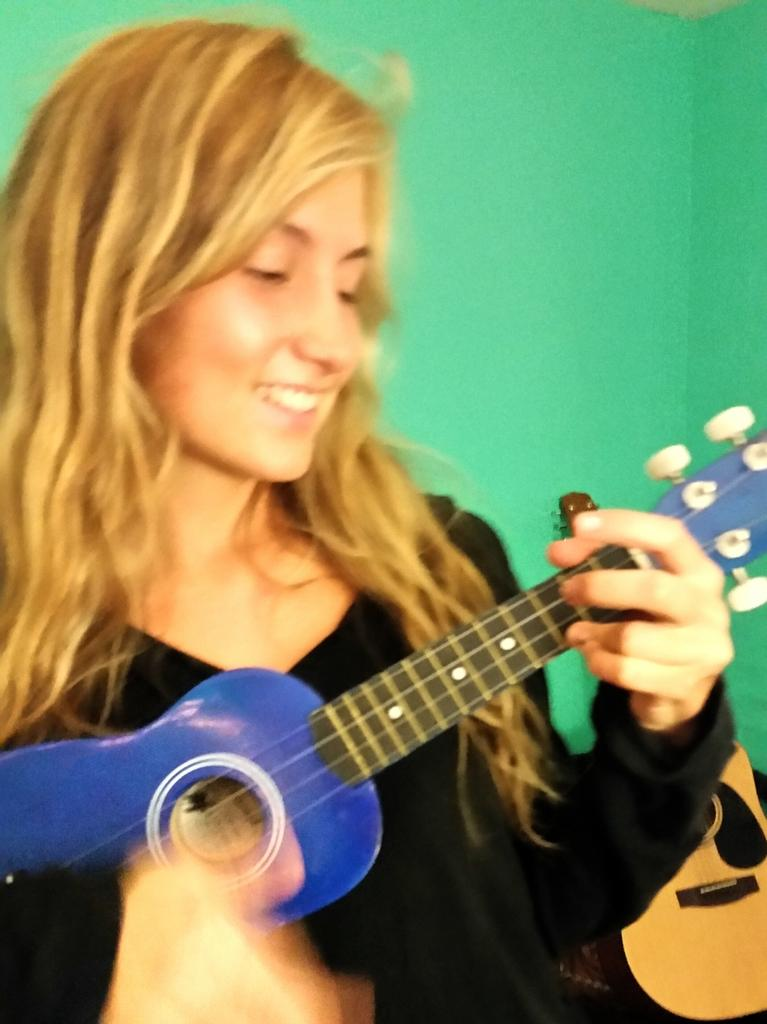Who is the main subject in the image? There is a lady in the image. What is the lady wearing? The lady is wearing a black shirt. What is the lady holding in the image? The lady is holding a guitar. What is the lady doing with the guitar? The lady is playing the guitar. Can you see any other guitars in the image? Yes, there is another guitar visible behind the lady. What type of caption is written on the guitar in the image? There is no caption written on the guitar in the image. What amusement park can be seen in the background of the image? There is no amusement park visible in the image; it features a lady playing a guitar. 